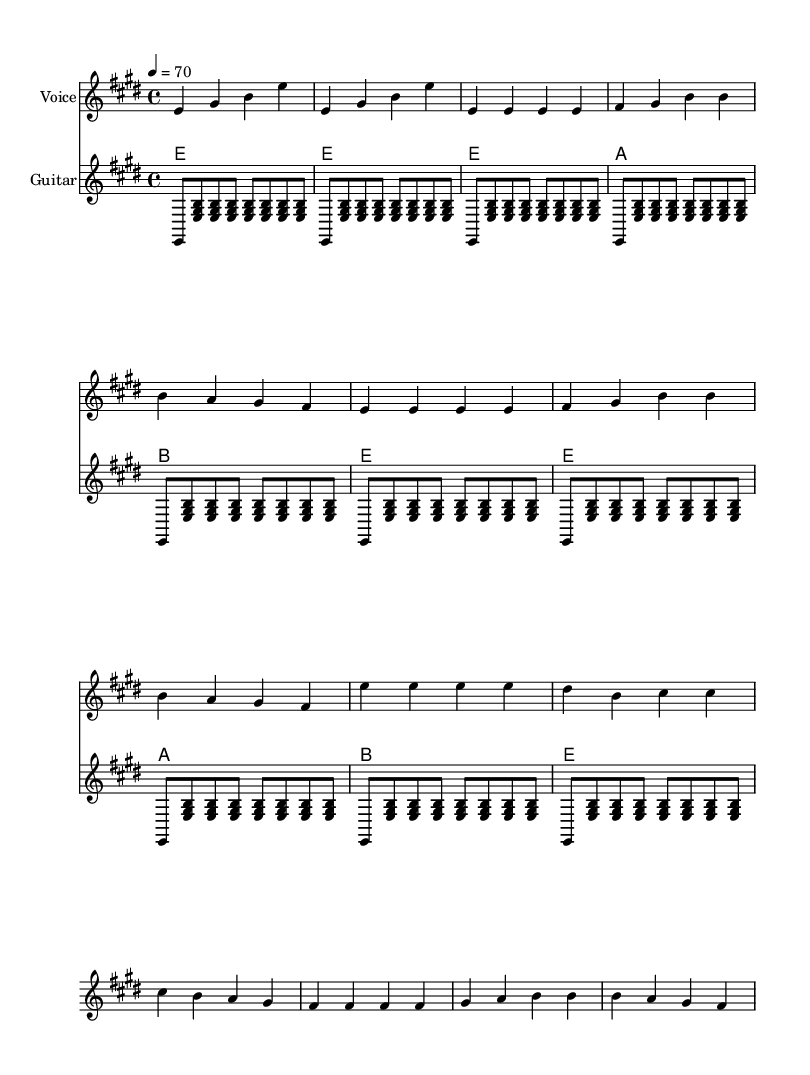What is the key signature of this music? The key signature is indicated at the beginning of the staff and shows two sharps, which correspond to F sharp and C sharp. This identifies the key as E major.
Answer: E major What is the time signature of this music? The time signature is found at the beginning of the music, represented by the fraction 4/4, meaning there are four beats in a measure and the quarter note gets one beat.
Answer: 4/4 What is the tempo marking of this piece? The tempo information is specified in beats per minute (BPM) at the beginning of the score, where it states 4 equals 70, indicating a speed of 70 beats per minute.
Answer: 70 How many measures are in the verse section? To determine this, we count the measures within the segment labeled as the verse in the score. There are four measures present in the verse section.
Answer: 4 What is the primary chord used in the chorus? The chorus contains repeated chords, which can be identified by looking at the chord names beneath the staff. The first chord indicated is E major, making it the primary chord used.
Answer: E major What instruments are featured in this piece? The music indicates two distinct staves, one for the voice and another for the guitar, meaning these two instruments are employed in the piece.
Answer: Voice and Guitar What is the overall structure of the piece indicated in the music? The structure is shown by the arrangement of sections within the score: it begins with an intro, followed by a verse and a chorus, giving us a clear structure of intro-verse-chorus.
Answer: Intro, Verse, Chorus 